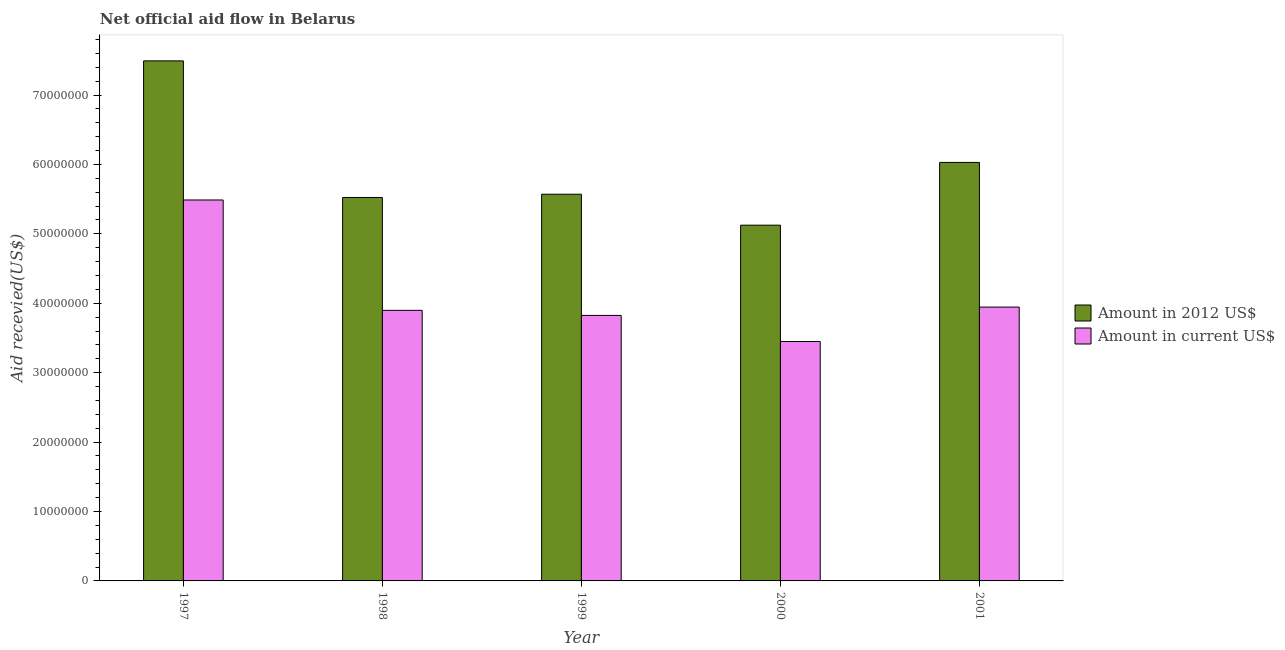Are the number of bars per tick equal to the number of legend labels?
Make the answer very short. Yes. Are the number of bars on each tick of the X-axis equal?
Offer a terse response. Yes. How many bars are there on the 1st tick from the left?
Your answer should be very brief. 2. How many bars are there on the 1st tick from the right?
Offer a very short reply. 2. What is the label of the 4th group of bars from the left?
Provide a short and direct response. 2000. In how many cases, is the number of bars for a given year not equal to the number of legend labels?
Keep it short and to the point. 0. What is the amount of aid received(expressed in us$) in 1997?
Provide a succinct answer. 5.49e+07. Across all years, what is the maximum amount of aid received(expressed in us$)?
Provide a succinct answer. 5.49e+07. Across all years, what is the minimum amount of aid received(expressed in us$)?
Provide a short and direct response. 3.45e+07. In which year was the amount of aid received(expressed in 2012 us$) maximum?
Provide a succinct answer. 1997. In which year was the amount of aid received(expressed in 2012 us$) minimum?
Provide a short and direct response. 2000. What is the total amount of aid received(expressed in us$) in the graph?
Provide a succinct answer. 2.06e+08. What is the difference between the amount of aid received(expressed in 2012 us$) in 1998 and that in 2000?
Keep it short and to the point. 3.99e+06. What is the difference between the amount of aid received(expressed in 2012 us$) in 2000 and the amount of aid received(expressed in us$) in 2001?
Your response must be concise. -9.04e+06. What is the average amount of aid received(expressed in 2012 us$) per year?
Provide a succinct answer. 5.95e+07. In the year 1998, what is the difference between the amount of aid received(expressed in 2012 us$) and amount of aid received(expressed in us$)?
Your answer should be compact. 0. In how many years, is the amount of aid received(expressed in us$) greater than 6000000 US$?
Provide a succinct answer. 5. What is the ratio of the amount of aid received(expressed in us$) in 1998 to that in 2001?
Provide a short and direct response. 0.99. Is the amount of aid received(expressed in us$) in 1998 less than that in 1999?
Offer a terse response. No. Is the difference between the amount of aid received(expressed in us$) in 2000 and 2001 greater than the difference between the amount of aid received(expressed in 2012 us$) in 2000 and 2001?
Your answer should be compact. No. What is the difference between the highest and the second highest amount of aid received(expressed in 2012 us$)?
Your answer should be very brief. 1.46e+07. What is the difference between the highest and the lowest amount of aid received(expressed in 2012 us$)?
Keep it short and to the point. 2.37e+07. Is the sum of the amount of aid received(expressed in us$) in 1998 and 2000 greater than the maximum amount of aid received(expressed in 2012 us$) across all years?
Keep it short and to the point. Yes. What does the 1st bar from the left in 1999 represents?
Your answer should be compact. Amount in 2012 US$. What does the 1st bar from the right in 1997 represents?
Offer a very short reply. Amount in current US$. How many bars are there?
Offer a very short reply. 10. Are all the bars in the graph horizontal?
Provide a short and direct response. No. How many years are there in the graph?
Make the answer very short. 5. What is the difference between two consecutive major ticks on the Y-axis?
Make the answer very short. 1.00e+07. Does the graph contain any zero values?
Offer a very short reply. No. Where does the legend appear in the graph?
Ensure brevity in your answer.  Center right. How many legend labels are there?
Provide a short and direct response. 2. How are the legend labels stacked?
Keep it short and to the point. Vertical. What is the title of the graph?
Provide a short and direct response. Net official aid flow in Belarus. Does "Males" appear as one of the legend labels in the graph?
Your response must be concise. No. What is the label or title of the X-axis?
Give a very brief answer. Year. What is the label or title of the Y-axis?
Offer a very short reply. Aid recevied(US$). What is the Aid recevied(US$) of Amount in 2012 US$ in 1997?
Give a very brief answer. 7.49e+07. What is the Aid recevied(US$) in Amount in current US$ in 1997?
Your answer should be very brief. 5.49e+07. What is the Aid recevied(US$) in Amount in 2012 US$ in 1998?
Provide a short and direct response. 5.52e+07. What is the Aid recevied(US$) of Amount in current US$ in 1998?
Make the answer very short. 3.90e+07. What is the Aid recevied(US$) of Amount in 2012 US$ in 1999?
Provide a succinct answer. 5.57e+07. What is the Aid recevied(US$) of Amount in current US$ in 1999?
Make the answer very short. 3.82e+07. What is the Aid recevied(US$) of Amount in 2012 US$ in 2000?
Your response must be concise. 5.12e+07. What is the Aid recevied(US$) of Amount in current US$ in 2000?
Keep it short and to the point. 3.45e+07. What is the Aid recevied(US$) of Amount in 2012 US$ in 2001?
Your answer should be very brief. 6.03e+07. What is the Aid recevied(US$) in Amount in current US$ in 2001?
Offer a very short reply. 3.94e+07. Across all years, what is the maximum Aid recevied(US$) of Amount in 2012 US$?
Your answer should be very brief. 7.49e+07. Across all years, what is the maximum Aid recevied(US$) of Amount in current US$?
Your response must be concise. 5.49e+07. Across all years, what is the minimum Aid recevied(US$) in Amount in 2012 US$?
Make the answer very short. 5.12e+07. Across all years, what is the minimum Aid recevied(US$) in Amount in current US$?
Offer a terse response. 3.45e+07. What is the total Aid recevied(US$) in Amount in 2012 US$ in the graph?
Offer a terse response. 2.97e+08. What is the total Aid recevied(US$) of Amount in current US$ in the graph?
Your answer should be compact. 2.06e+08. What is the difference between the Aid recevied(US$) in Amount in 2012 US$ in 1997 and that in 1998?
Offer a terse response. 1.97e+07. What is the difference between the Aid recevied(US$) of Amount in current US$ in 1997 and that in 1998?
Provide a short and direct response. 1.59e+07. What is the difference between the Aid recevied(US$) in Amount in 2012 US$ in 1997 and that in 1999?
Your response must be concise. 1.92e+07. What is the difference between the Aid recevied(US$) of Amount in current US$ in 1997 and that in 1999?
Offer a terse response. 1.66e+07. What is the difference between the Aid recevied(US$) in Amount in 2012 US$ in 1997 and that in 2000?
Your answer should be very brief. 2.37e+07. What is the difference between the Aid recevied(US$) in Amount in current US$ in 1997 and that in 2000?
Provide a succinct answer. 2.04e+07. What is the difference between the Aid recevied(US$) of Amount in 2012 US$ in 1997 and that in 2001?
Ensure brevity in your answer.  1.46e+07. What is the difference between the Aid recevied(US$) in Amount in current US$ in 1997 and that in 2001?
Provide a succinct answer. 1.54e+07. What is the difference between the Aid recevied(US$) in Amount in 2012 US$ in 1998 and that in 1999?
Your answer should be very brief. -4.70e+05. What is the difference between the Aid recevied(US$) in Amount in current US$ in 1998 and that in 1999?
Your response must be concise. 7.30e+05. What is the difference between the Aid recevied(US$) in Amount in 2012 US$ in 1998 and that in 2000?
Give a very brief answer. 3.99e+06. What is the difference between the Aid recevied(US$) of Amount in current US$ in 1998 and that in 2000?
Offer a very short reply. 4.49e+06. What is the difference between the Aid recevied(US$) in Amount in 2012 US$ in 1998 and that in 2001?
Ensure brevity in your answer.  -5.05e+06. What is the difference between the Aid recevied(US$) of Amount in current US$ in 1998 and that in 2001?
Offer a very short reply. -4.70e+05. What is the difference between the Aid recevied(US$) of Amount in 2012 US$ in 1999 and that in 2000?
Offer a terse response. 4.46e+06. What is the difference between the Aid recevied(US$) of Amount in current US$ in 1999 and that in 2000?
Your answer should be very brief. 3.76e+06. What is the difference between the Aid recevied(US$) in Amount in 2012 US$ in 1999 and that in 2001?
Make the answer very short. -4.58e+06. What is the difference between the Aid recevied(US$) in Amount in current US$ in 1999 and that in 2001?
Your answer should be very brief. -1.20e+06. What is the difference between the Aid recevied(US$) in Amount in 2012 US$ in 2000 and that in 2001?
Offer a terse response. -9.04e+06. What is the difference between the Aid recevied(US$) in Amount in current US$ in 2000 and that in 2001?
Offer a very short reply. -4.96e+06. What is the difference between the Aid recevied(US$) in Amount in 2012 US$ in 1997 and the Aid recevied(US$) in Amount in current US$ in 1998?
Offer a very short reply. 3.59e+07. What is the difference between the Aid recevied(US$) in Amount in 2012 US$ in 1997 and the Aid recevied(US$) in Amount in current US$ in 1999?
Offer a very short reply. 3.67e+07. What is the difference between the Aid recevied(US$) in Amount in 2012 US$ in 1997 and the Aid recevied(US$) in Amount in current US$ in 2000?
Offer a terse response. 4.04e+07. What is the difference between the Aid recevied(US$) of Amount in 2012 US$ in 1997 and the Aid recevied(US$) of Amount in current US$ in 2001?
Make the answer very short. 3.55e+07. What is the difference between the Aid recevied(US$) of Amount in 2012 US$ in 1998 and the Aid recevied(US$) of Amount in current US$ in 1999?
Ensure brevity in your answer.  1.70e+07. What is the difference between the Aid recevied(US$) of Amount in 2012 US$ in 1998 and the Aid recevied(US$) of Amount in current US$ in 2000?
Your answer should be compact. 2.08e+07. What is the difference between the Aid recevied(US$) in Amount in 2012 US$ in 1998 and the Aid recevied(US$) in Amount in current US$ in 2001?
Offer a terse response. 1.58e+07. What is the difference between the Aid recevied(US$) in Amount in 2012 US$ in 1999 and the Aid recevied(US$) in Amount in current US$ in 2000?
Provide a succinct answer. 2.12e+07. What is the difference between the Aid recevied(US$) of Amount in 2012 US$ in 1999 and the Aid recevied(US$) of Amount in current US$ in 2001?
Your response must be concise. 1.63e+07. What is the difference between the Aid recevied(US$) of Amount in 2012 US$ in 2000 and the Aid recevied(US$) of Amount in current US$ in 2001?
Your response must be concise. 1.18e+07. What is the average Aid recevied(US$) of Amount in 2012 US$ per year?
Ensure brevity in your answer.  5.95e+07. What is the average Aid recevied(US$) in Amount in current US$ per year?
Provide a succinct answer. 4.12e+07. In the year 1997, what is the difference between the Aid recevied(US$) in Amount in 2012 US$ and Aid recevied(US$) in Amount in current US$?
Ensure brevity in your answer.  2.00e+07. In the year 1998, what is the difference between the Aid recevied(US$) of Amount in 2012 US$ and Aid recevied(US$) of Amount in current US$?
Offer a terse response. 1.63e+07. In the year 1999, what is the difference between the Aid recevied(US$) of Amount in 2012 US$ and Aid recevied(US$) of Amount in current US$?
Your response must be concise. 1.75e+07. In the year 2000, what is the difference between the Aid recevied(US$) in Amount in 2012 US$ and Aid recevied(US$) in Amount in current US$?
Make the answer very short. 1.68e+07. In the year 2001, what is the difference between the Aid recevied(US$) in Amount in 2012 US$ and Aid recevied(US$) in Amount in current US$?
Your answer should be very brief. 2.08e+07. What is the ratio of the Aid recevied(US$) of Amount in 2012 US$ in 1997 to that in 1998?
Your answer should be very brief. 1.36. What is the ratio of the Aid recevied(US$) of Amount in current US$ in 1997 to that in 1998?
Your answer should be very brief. 1.41. What is the ratio of the Aid recevied(US$) in Amount in 2012 US$ in 1997 to that in 1999?
Your answer should be compact. 1.34. What is the ratio of the Aid recevied(US$) of Amount in current US$ in 1997 to that in 1999?
Your answer should be compact. 1.43. What is the ratio of the Aid recevied(US$) in Amount in 2012 US$ in 1997 to that in 2000?
Give a very brief answer. 1.46. What is the ratio of the Aid recevied(US$) of Amount in current US$ in 1997 to that in 2000?
Your answer should be very brief. 1.59. What is the ratio of the Aid recevied(US$) of Amount in 2012 US$ in 1997 to that in 2001?
Keep it short and to the point. 1.24. What is the ratio of the Aid recevied(US$) in Amount in current US$ in 1997 to that in 2001?
Make the answer very short. 1.39. What is the ratio of the Aid recevied(US$) in Amount in 2012 US$ in 1998 to that in 1999?
Ensure brevity in your answer.  0.99. What is the ratio of the Aid recevied(US$) in Amount in current US$ in 1998 to that in 1999?
Ensure brevity in your answer.  1.02. What is the ratio of the Aid recevied(US$) in Amount in 2012 US$ in 1998 to that in 2000?
Ensure brevity in your answer.  1.08. What is the ratio of the Aid recevied(US$) of Amount in current US$ in 1998 to that in 2000?
Your answer should be very brief. 1.13. What is the ratio of the Aid recevied(US$) in Amount in 2012 US$ in 1998 to that in 2001?
Give a very brief answer. 0.92. What is the ratio of the Aid recevied(US$) of Amount in 2012 US$ in 1999 to that in 2000?
Provide a succinct answer. 1.09. What is the ratio of the Aid recevied(US$) in Amount in current US$ in 1999 to that in 2000?
Keep it short and to the point. 1.11. What is the ratio of the Aid recevied(US$) in Amount in 2012 US$ in 1999 to that in 2001?
Offer a terse response. 0.92. What is the ratio of the Aid recevied(US$) of Amount in current US$ in 1999 to that in 2001?
Provide a short and direct response. 0.97. What is the ratio of the Aid recevied(US$) of Amount in 2012 US$ in 2000 to that in 2001?
Your answer should be compact. 0.85. What is the ratio of the Aid recevied(US$) in Amount in current US$ in 2000 to that in 2001?
Ensure brevity in your answer.  0.87. What is the difference between the highest and the second highest Aid recevied(US$) of Amount in 2012 US$?
Provide a succinct answer. 1.46e+07. What is the difference between the highest and the second highest Aid recevied(US$) of Amount in current US$?
Make the answer very short. 1.54e+07. What is the difference between the highest and the lowest Aid recevied(US$) in Amount in 2012 US$?
Make the answer very short. 2.37e+07. What is the difference between the highest and the lowest Aid recevied(US$) of Amount in current US$?
Offer a terse response. 2.04e+07. 